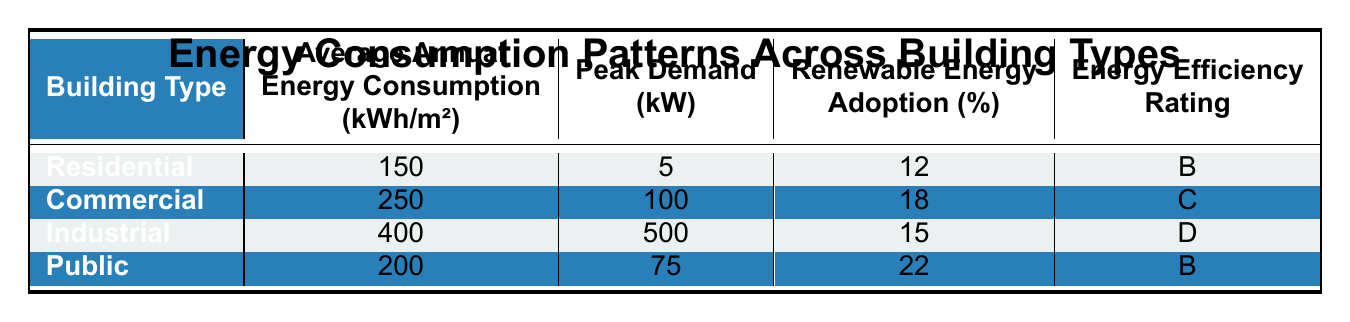What is the average annual energy consumption for residential buildings? The table indicates that the average annual energy consumption for residential buildings is listed as 150 kWh/m².
Answer: 150 kWh/m² Which building type has the highest peak demand? The peak demand values for each building type are: Residential (5 kW), Commercial (100 kW), Industrial (500 kW), and Public (75 kW). The Industrial building has the highest value at 500 kW.
Answer: Industrial What is the renewable energy adoption percentage for public buildings? According to the table, public buildings have a renewable energy adoption percentage of 22%.
Answer: 22% Is the energy efficiency rating for commercial buildings better, equal to, or worse than that for residential buildings? The table specifies that the energy efficiency rating for commercial buildings is C and for residential buildings is B. Since B is better than C, commercial buildings are worse in rating than residential buildings.
Answer: Worse What is the difference in average annual energy consumption between industrial and commercial buildings? The average annual energy consumption for industrial buildings is 400 kWh/m², and for commercial buildings, it is 250 kWh/m². The difference is 400 - 250 = 150 kWh/m².
Answer: 150 kWh/m² What building type has the lowest renewable energy adoption rate? The percentages of renewable energy adoption are: Residential (12%), Commercial (18%), Industrial (15%), and Public (22%). The lowest percentage is for residential buildings at 12%.
Answer: Residential Which two building types have the same energy efficiency rating? The energy efficiency ratings are: Residential (B), Commercial (C), Industrial (D), and Public (B). Residential and Public buildings share the same rating of B.
Answer: Residential and Public Calculate the average renewable energy adoption percentage across all building types. The renewable energy adoption percentages are: 12, 18, 15, and 22. The total is 12 + 18 + 15 + 22 = 67. The average is 67/4 = 16.75%.
Answer: 16.75% Which building type requires the least amount of energy? From the average annual energy consumption data, residential buildings require the least energy at 150 kWh/m².
Answer: Residential Is it true that industrial buildings have a higher energy efficiency rating than public buildings? The energy efficiency rating for industrial buildings is D, and for public buildings, it is B. Since D is worse than B, the statement is false.
Answer: False 